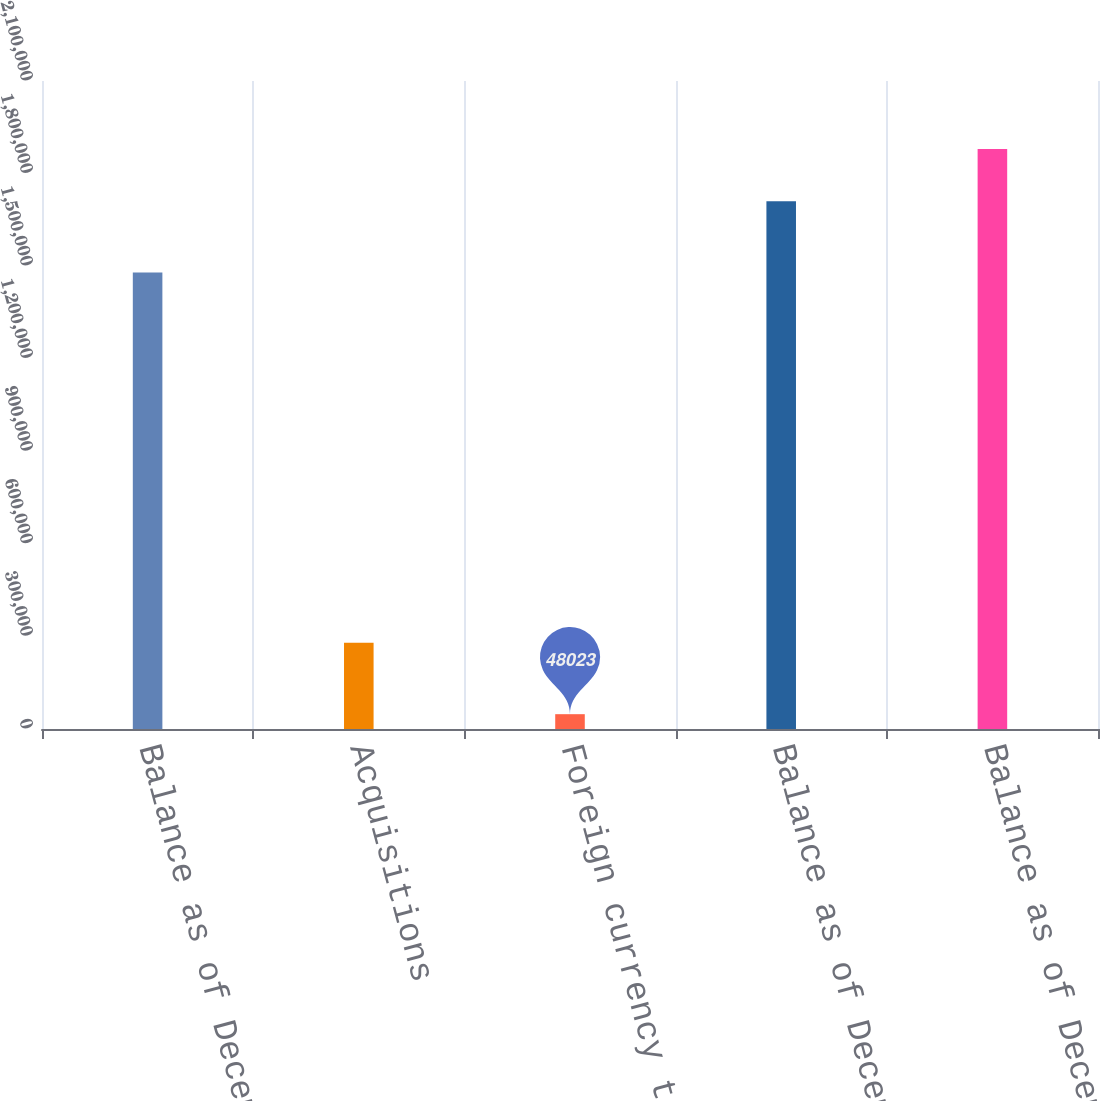<chart> <loc_0><loc_0><loc_500><loc_500><bar_chart><fcel>Balance as of December 28 2013<fcel>Acquisitions<fcel>Foreign currency translation<fcel>Balance as of December 27 2014<fcel>Balance as of December 26 2015<nl><fcel>1.47918e+06<fcel>279400<fcel>48023<fcel>1.71055e+06<fcel>1.87995e+06<nl></chart> 